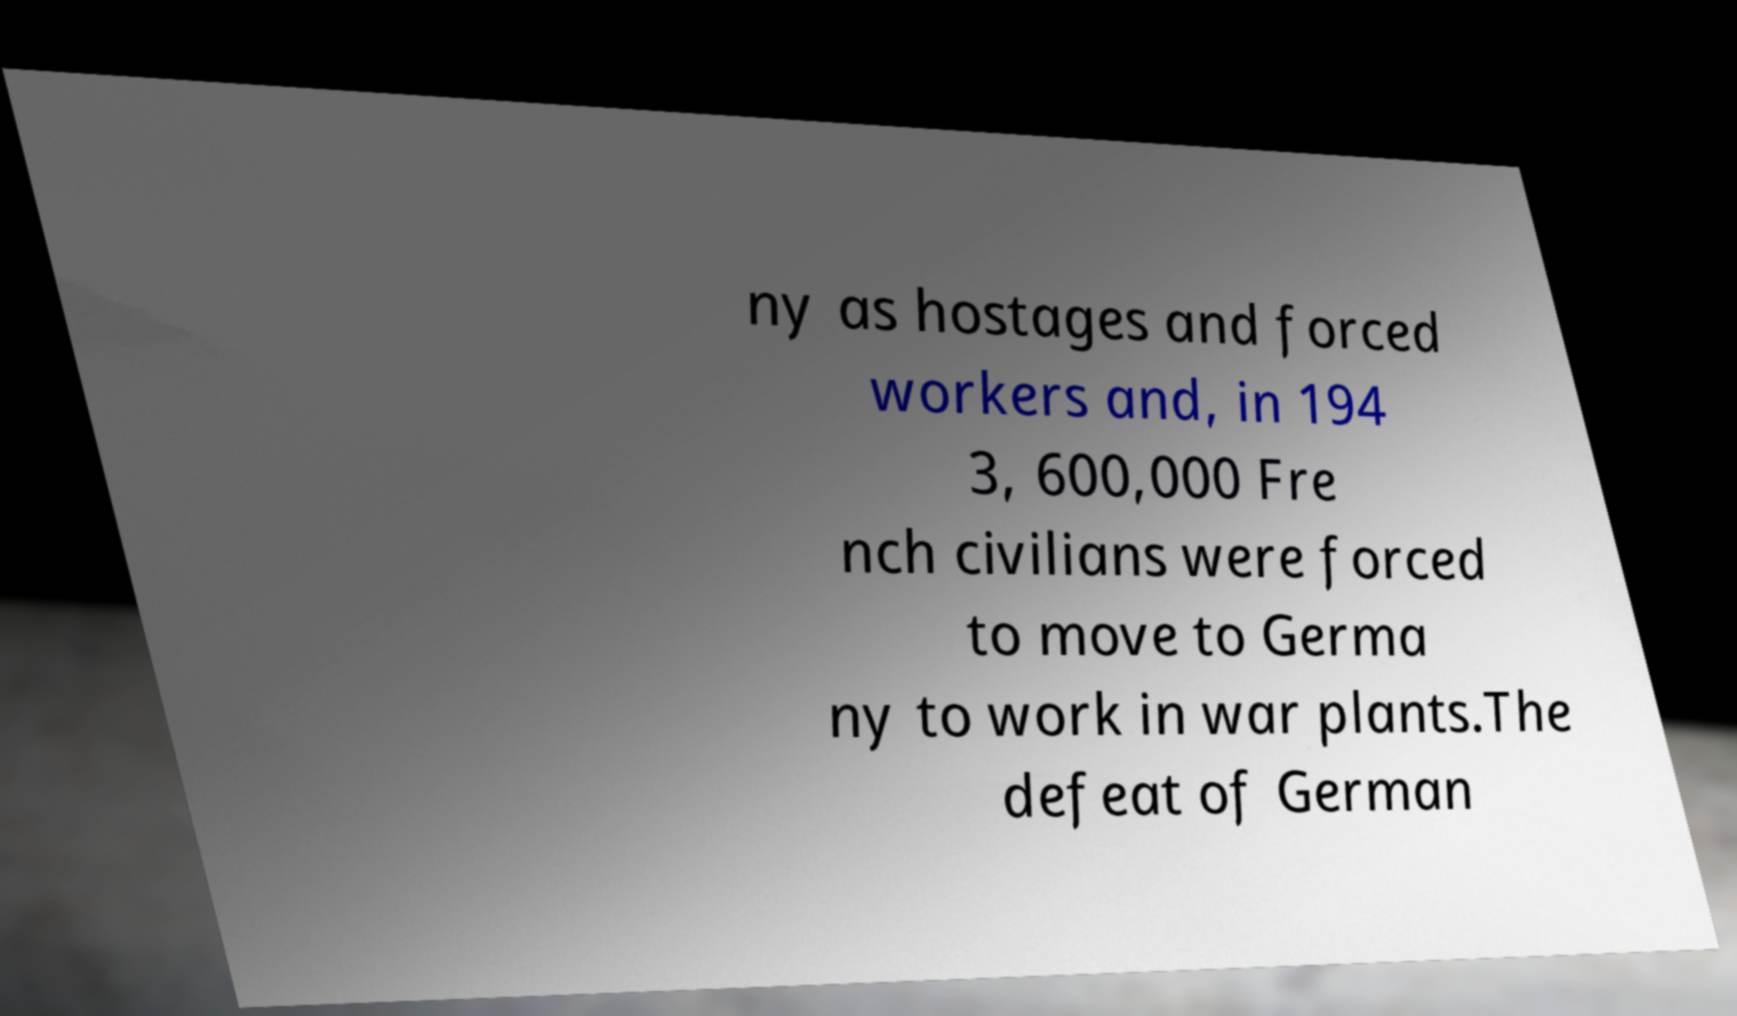There's text embedded in this image that I need extracted. Can you transcribe it verbatim? ny as hostages and forced workers and, in 194 3, 600,000 Fre nch civilians were forced to move to Germa ny to work in war plants.The defeat of German 